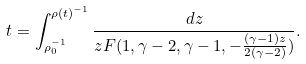<formula> <loc_0><loc_0><loc_500><loc_500>t = \int _ { \rho _ { 0 } ^ { - 1 } } ^ { \rho ( t ) ^ { - 1 } } \frac { d z } { z F ( 1 , \gamma - 2 , \gamma - 1 , - \frac { ( \gamma - 1 ) z } { 2 ( \gamma - 2 ) } ) } .</formula> 